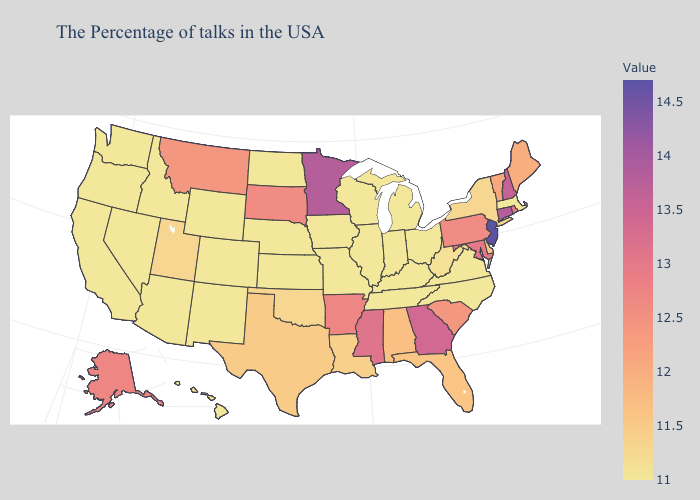Does Montana have the lowest value in the West?
Write a very short answer. No. Which states hav the highest value in the MidWest?
Answer briefly. Minnesota. Does Oklahoma have the lowest value in the USA?
Concise answer only. No. Among the states that border Maryland , which have the highest value?
Answer briefly. Pennsylvania. Among the states that border Texas , which have the highest value?
Answer briefly. Arkansas. Does Georgia have the lowest value in the South?
Be succinct. No. Does Minnesota have the highest value in the MidWest?
Concise answer only. Yes. Among the states that border California , which have the highest value?
Short answer required. Arizona, Nevada, Oregon. Among the states that border West Virginia , does Pennsylvania have the lowest value?
Write a very short answer. No. 